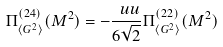<formula> <loc_0><loc_0><loc_500><loc_500>\Pi ^ { ( 2 4 ) } _ { \langle G ^ { 2 } \rangle } ( M ^ { 2 } ) = - \frac { \ u u } { 6 \sqrt { 2 } } \Pi ^ { ( 2 2 ) } _ { \langle G ^ { 2 } \rangle } ( M ^ { 2 } )</formula> 